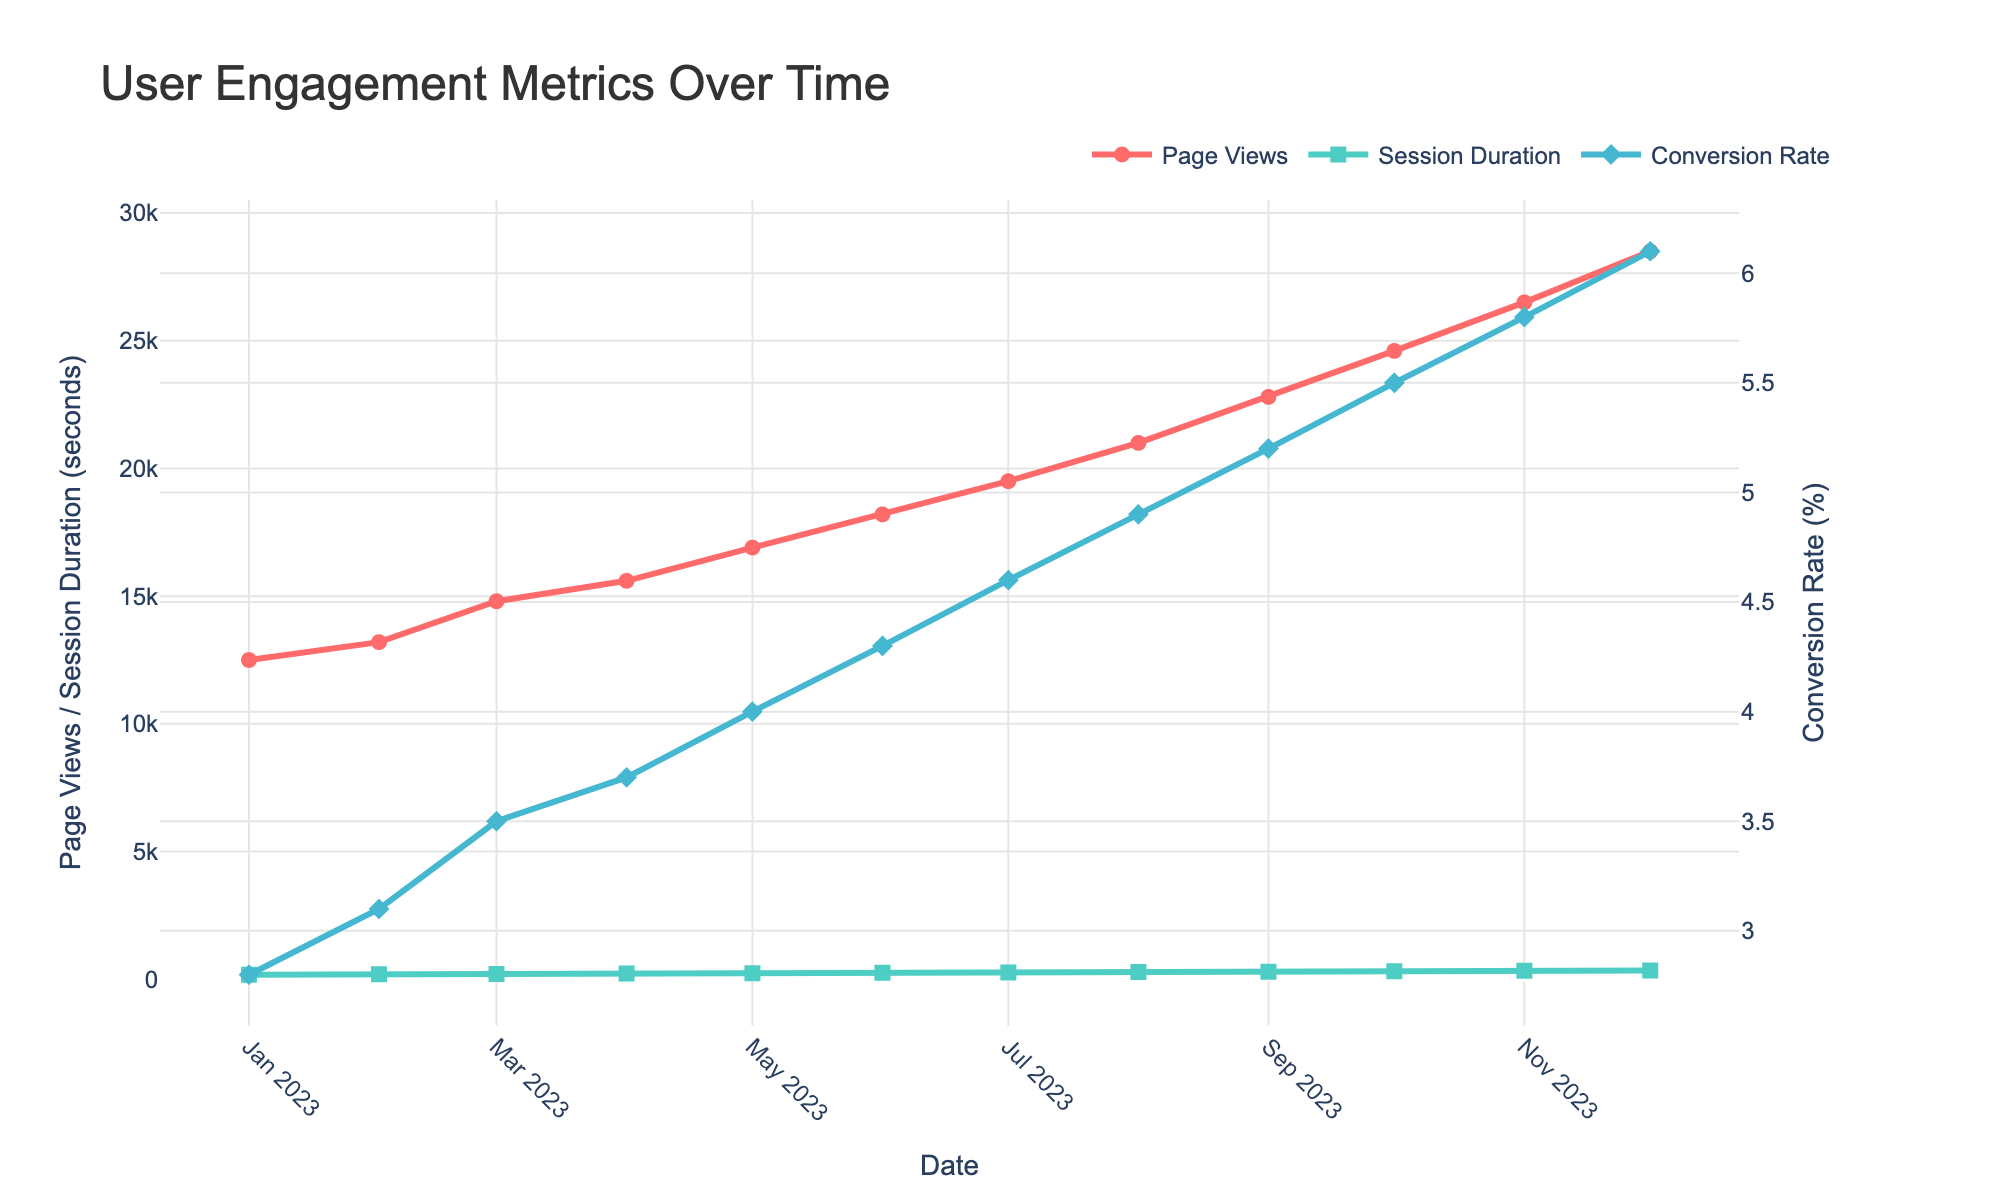What metric saw the most significant increase overall? By observing the highest increase, we see that Page Views increased from 12,500 to 28,500, while Session Duration went from 180 to 345 seconds, and Conversion Rate rose from 2.8% to 6.1%. The absolute increase is most significant for Page Views, which increased by 16,000.
Answer: Page Views In which month was the Session Duration the highest? Looking at the specific points along the line representing Session Duration, the peak is in December with a duration of 345 seconds.
Answer: December What was the difference in Conversion Rate between January and December? January had a Conversion Rate of 2.8% and December had 6.1%. The difference is 6.1% - 2.8% = 3.3%.
Answer: 3.3% How did Page Views change from June to July? Comparing Page Views in June (18,200) and July (19,500), the change is 19,500 - 18,200 = 1,300.
Answer: Increased by 1,300 Which metric grew at the fastest rate over 2023? Calculate the percentage growth for each metric from January to December: 
- Page Views: ((28,500 - 12,500) / 12,500) * 100% = 128%
- Session Duration: ((345 - 180) / 180) * 100% = 91.7%
- Conversion Rate: ((6.1 - 2.8) / 2.8) * 100% = 117.9%
Page Views have the highest growth rate at 128%.
Answer: Page Views What is the average Session Duration for Q2 (April, May, June)? Summing the Session Durations for April (225), May (240), and June (255), we get 720. The average is 720 / 3 = 240 seconds.
Answer: 240 seconds Did Page Views and Conversion Rate increase simultaneously every month? By examining the trends, both Page Views and Conversion Rate show a continuous increase each month from January to December with no dips or decreases.
Answer: Yes What is the difference in Session Duration between August and November? The Session Duration in August is 285 seconds, and in November it is 330 seconds. The difference is 330 - 285 = 45 seconds.
Answer: 45 seconds Identify the month with the greatest monthly increase in Page Views. Observing the Page Views line, the largest jump is from August (21,000) to September (22,800), which is an increase of 1,800.
Answer: September Compare the increase rates of Conversion Rate and Page Views between March and June. - Page Views: March (14,800) to June (18,200) = 18,200 - 14,800 = 3,400
- Conversion Rate: March (3.5%) to June (4.3%) = 4.3% - 3.5% = 0.8%
Relative increase rate:
- Page Views: (3,400 / 14,800) * 100% = 22.97%
- Conversion Rate: (0.8 / 3.5) * 100% = 22.86%
Both have approximately the same relative increase rate of about 23%.
Answer: Approximately equal 